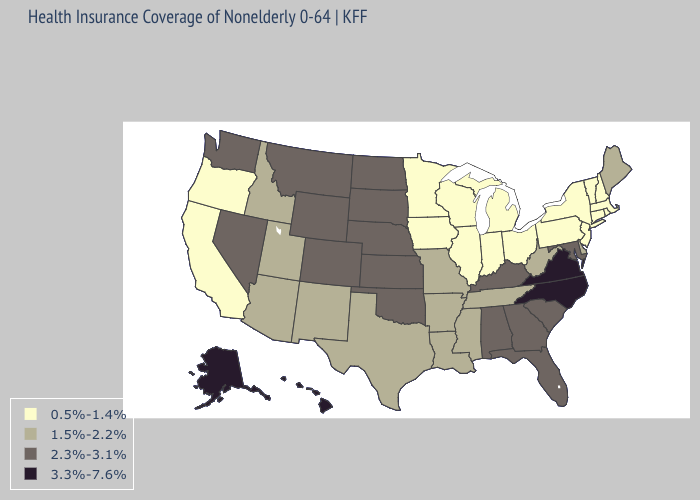Among the states that border Arkansas , does Oklahoma have the lowest value?
Keep it brief. No. Does Michigan have the lowest value in the USA?
Quick response, please. Yes. What is the value of Colorado?
Give a very brief answer. 2.3%-3.1%. Does the first symbol in the legend represent the smallest category?
Short answer required. Yes. What is the value of Ohio?
Give a very brief answer. 0.5%-1.4%. What is the value of Wisconsin?
Keep it brief. 0.5%-1.4%. Which states have the lowest value in the Northeast?
Concise answer only. Connecticut, Massachusetts, New Hampshire, New Jersey, New York, Pennsylvania, Rhode Island, Vermont. What is the value of Michigan?
Concise answer only. 0.5%-1.4%. Which states have the lowest value in the USA?
Answer briefly. California, Connecticut, Illinois, Indiana, Iowa, Massachusetts, Michigan, Minnesota, New Hampshire, New Jersey, New York, Ohio, Oregon, Pennsylvania, Rhode Island, Vermont, Wisconsin. Which states have the lowest value in the West?
Give a very brief answer. California, Oregon. What is the value of Utah?
Short answer required. 1.5%-2.2%. Name the states that have a value in the range 2.3%-3.1%?
Give a very brief answer. Alabama, Colorado, Florida, Georgia, Kansas, Kentucky, Maryland, Montana, Nebraska, Nevada, North Dakota, Oklahoma, South Carolina, South Dakota, Washington, Wyoming. What is the value of Alabama?
Quick response, please. 2.3%-3.1%. Does Georgia have the lowest value in the South?
Give a very brief answer. No. What is the lowest value in states that border North Dakota?
Write a very short answer. 0.5%-1.4%. 